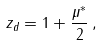<formula> <loc_0><loc_0><loc_500><loc_500>z _ { d } = 1 + \frac { \mu ^ { \ast } } { 2 } \, ,</formula> 